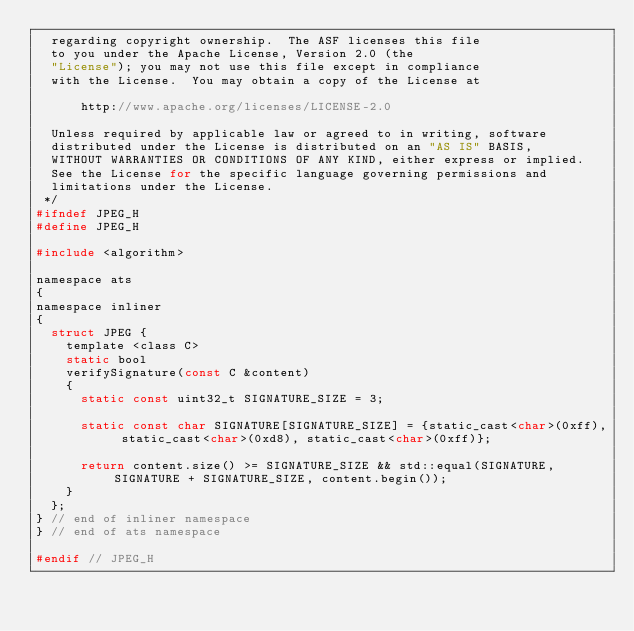<code> <loc_0><loc_0><loc_500><loc_500><_C_>  regarding copyright ownership.  The ASF licenses this file
  to you under the Apache License, Version 2.0 (the
  "License"); you may not use this file except in compliance
  with the License.  You may obtain a copy of the License at

      http://www.apache.org/licenses/LICENSE-2.0

  Unless required by applicable law or agreed to in writing, software
  distributed under the License is distributed on an "AS IS" BASIS,
  WITHOUT WARRANTIES OR CONDITIONS OF ANY KIND, either express or implied.
  See the License for the specific language governing permissions and
  limitations under the License.
 */
#ifndef JPEG_H
#define JPEG_H

#include <algorithm>

namespace ats
{
namespace inliner
{
  struct JPEG {
    template <class C>
    static bool
    verifySignature(const C &content)
    {
      static const uint32_t SIGNATURE_SIZE = 3;

      static const char SIGNATURE[SIGNATURE_SIZE] = {static_cast<char>(0xff), static_cast<char>(0xd8), static_cast<char>(0xff)};

      return content.size() >= SIGNATURE_SIZE && std::equal(SIGNATURE, SIGNATURE + SIGNATURE_SIZE, content.begin());
    }
  };
} // end of inliner namespace
} // end of ats namespace

#endif // JPEG_H
</code> 